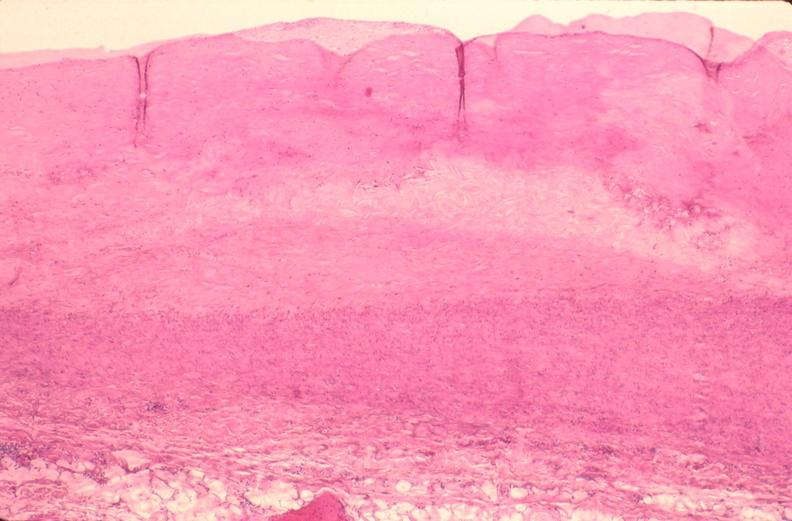where is this from?
Answer the question using a single word or phrase. Vasculature 